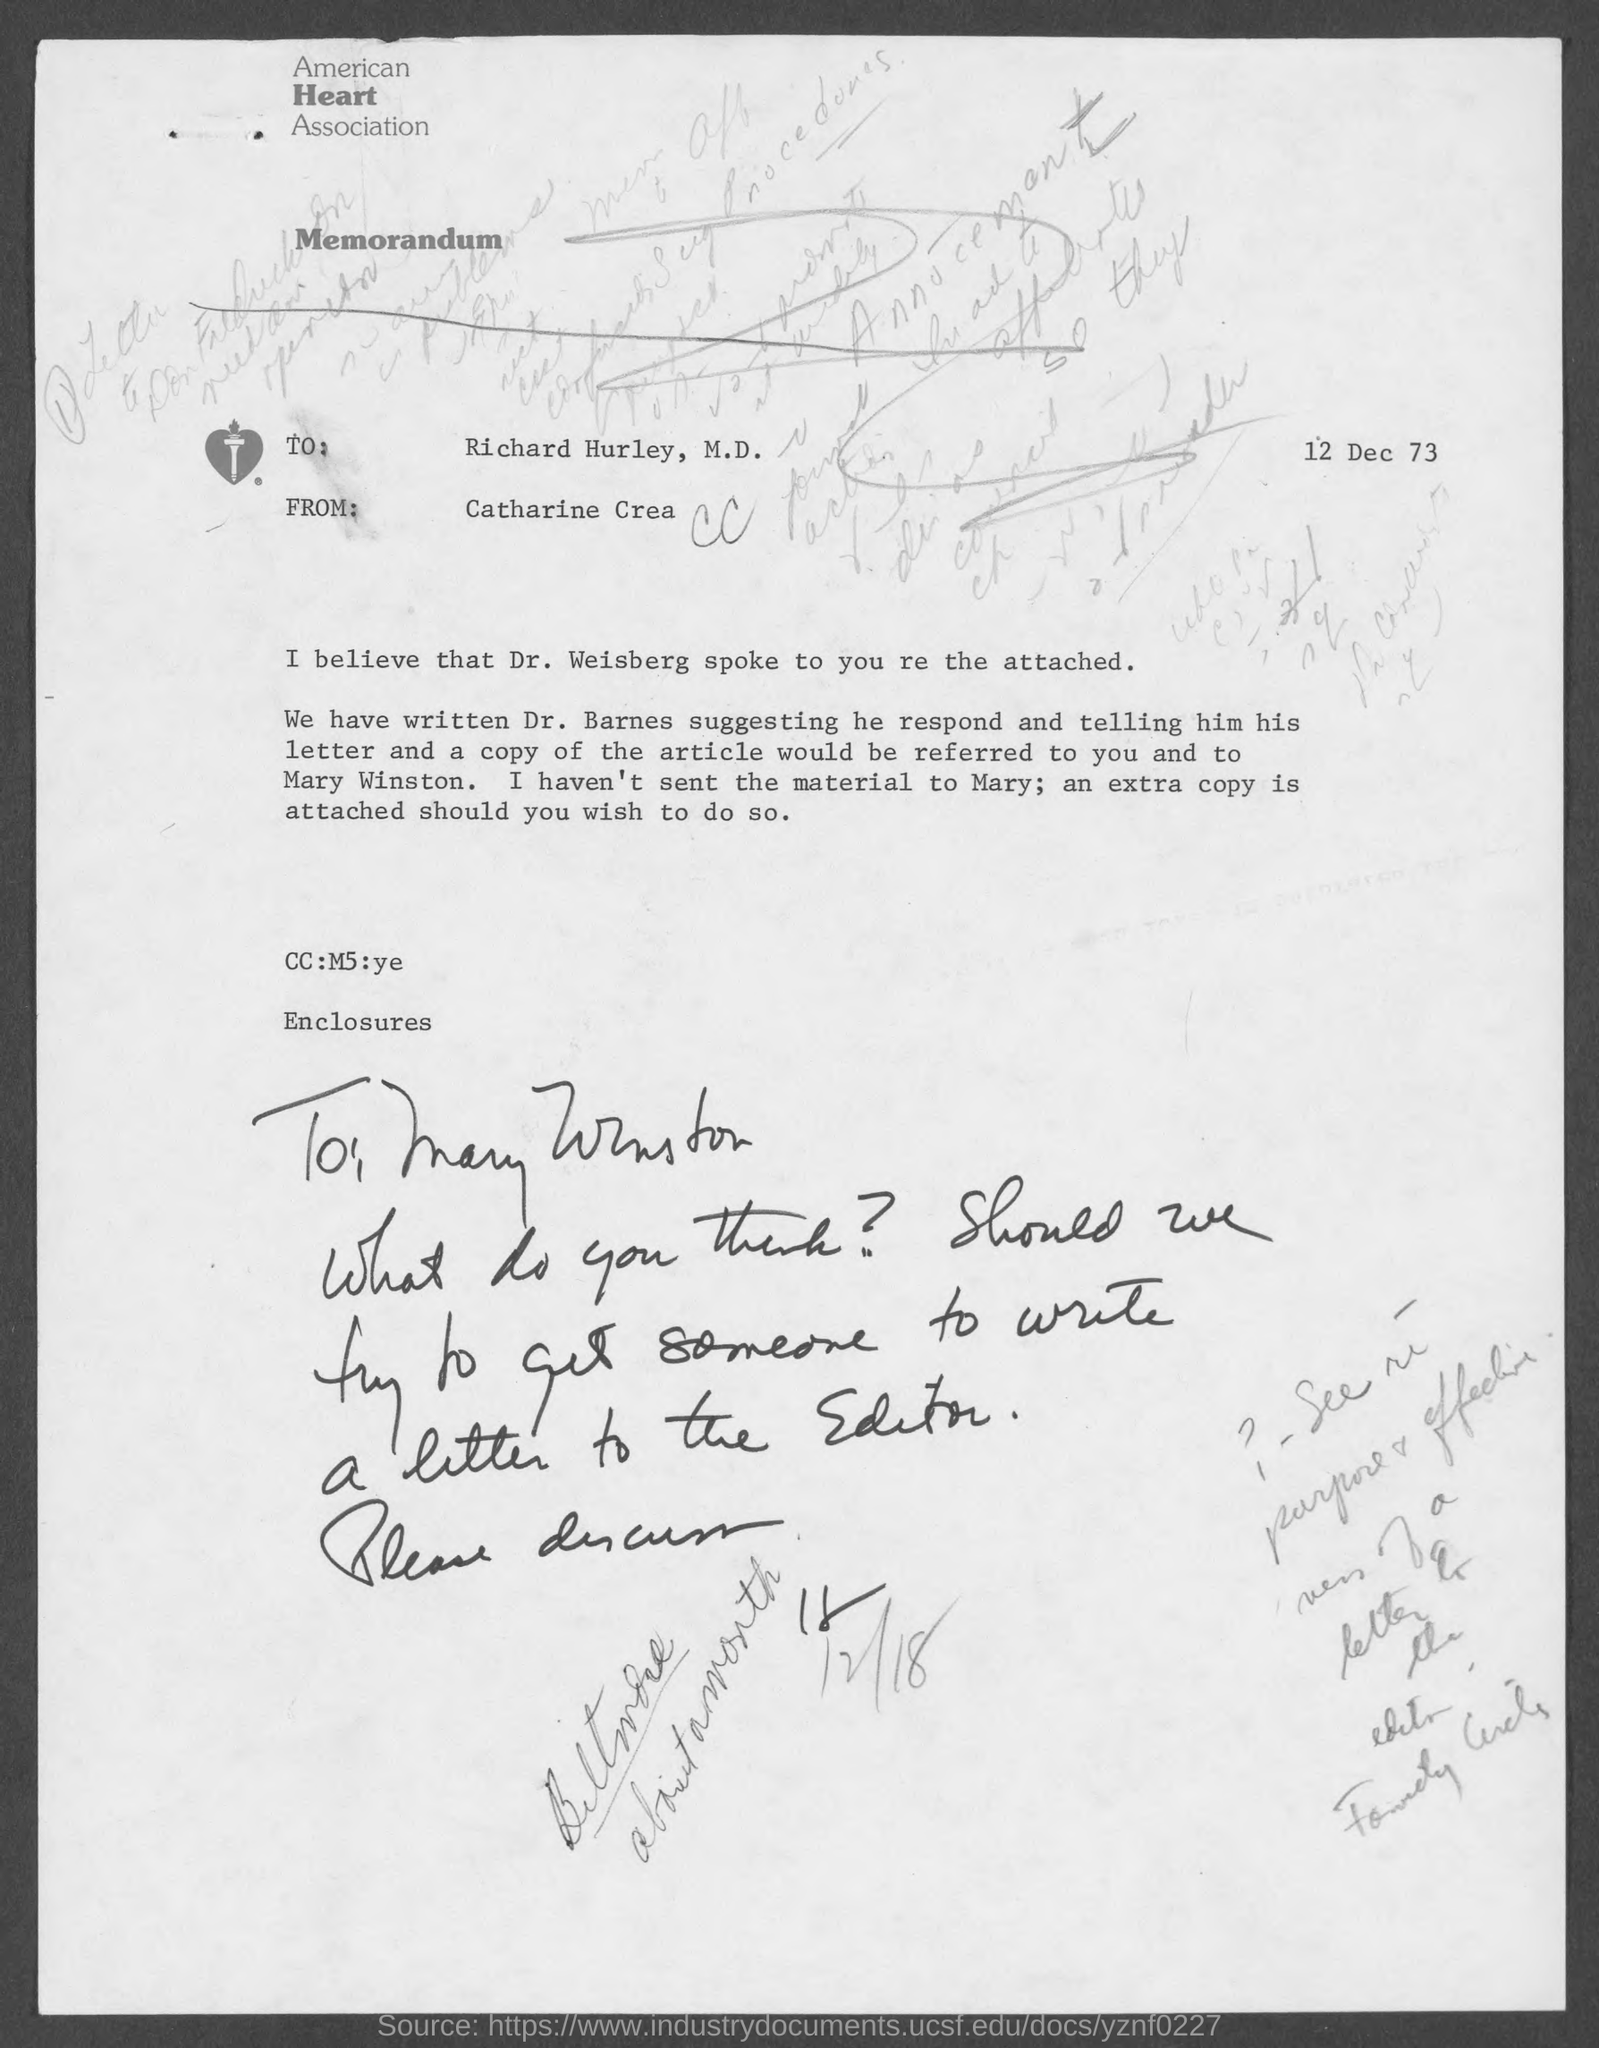What is the name of heart association at top of the page?
Keep it short and to the point. American Heart Association. When is the memorandum dated?
Ensure brevity in your answer.  12 Dec 73. Who wrote this memorandum ?
Keep it short and to the point. Catharine Crea. To whom is this memorandum written?
Your answer should be very brief. Richard Hurley, M.D. 